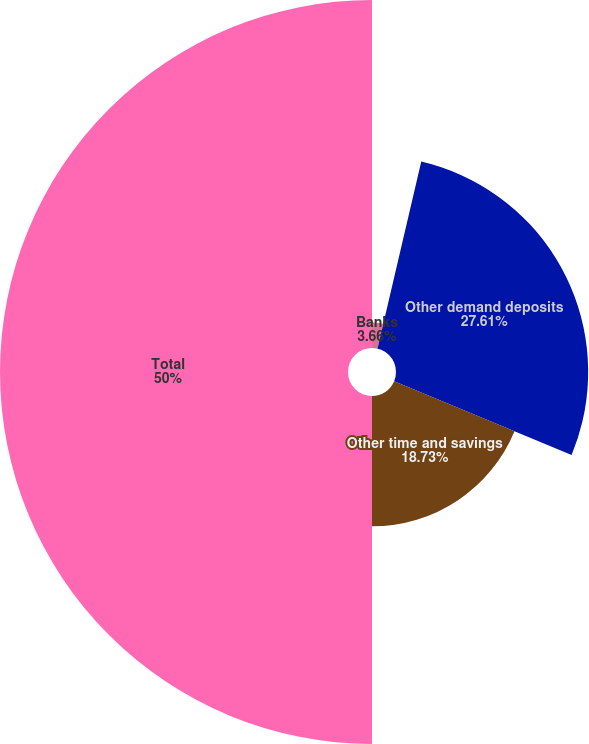Convert chart. <chart><loc_0><loc_0><loc_500><loc_500><pie_chart><fcel>Banks<fcel>Other demand deposits<fcel>Other time and savings<fcel>Total<nl><fcel>3.66%<fcel>27.61%<fcel>18.73%<fcel>50.0%<nl></chart> 